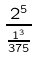Convert formula to latex. <formula><loc_0><loc_0><loc_500><loc_500>\frac { 2 ^ { 5 } } { \frac { 1 ^ { 3 } } { 3 7 5 } }</formula> 